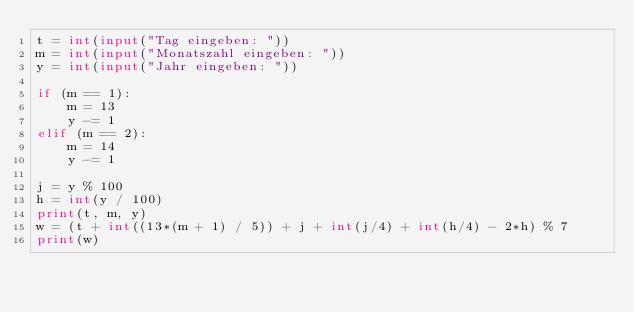Convert code to text. <code><loc_0><loc_0><loc_500><loc_500><_Python_>t = int(input("Tag eingeben: "))
m = int(input("Monatszahl eingeben: "))
y = int(input("Jahr eingeben: "))

if (m == 1):
    m = 13
    y -= 1
elif (m == 2):
    m = 14
    y -= 1

j = y % 100
h = int(y / 100)
print(t, m, y)
w = (t + int((13*(m + 1) / 5)) + j + int(j/4) + int(h/4) - 2*h) % 7
print(w)
</code> 